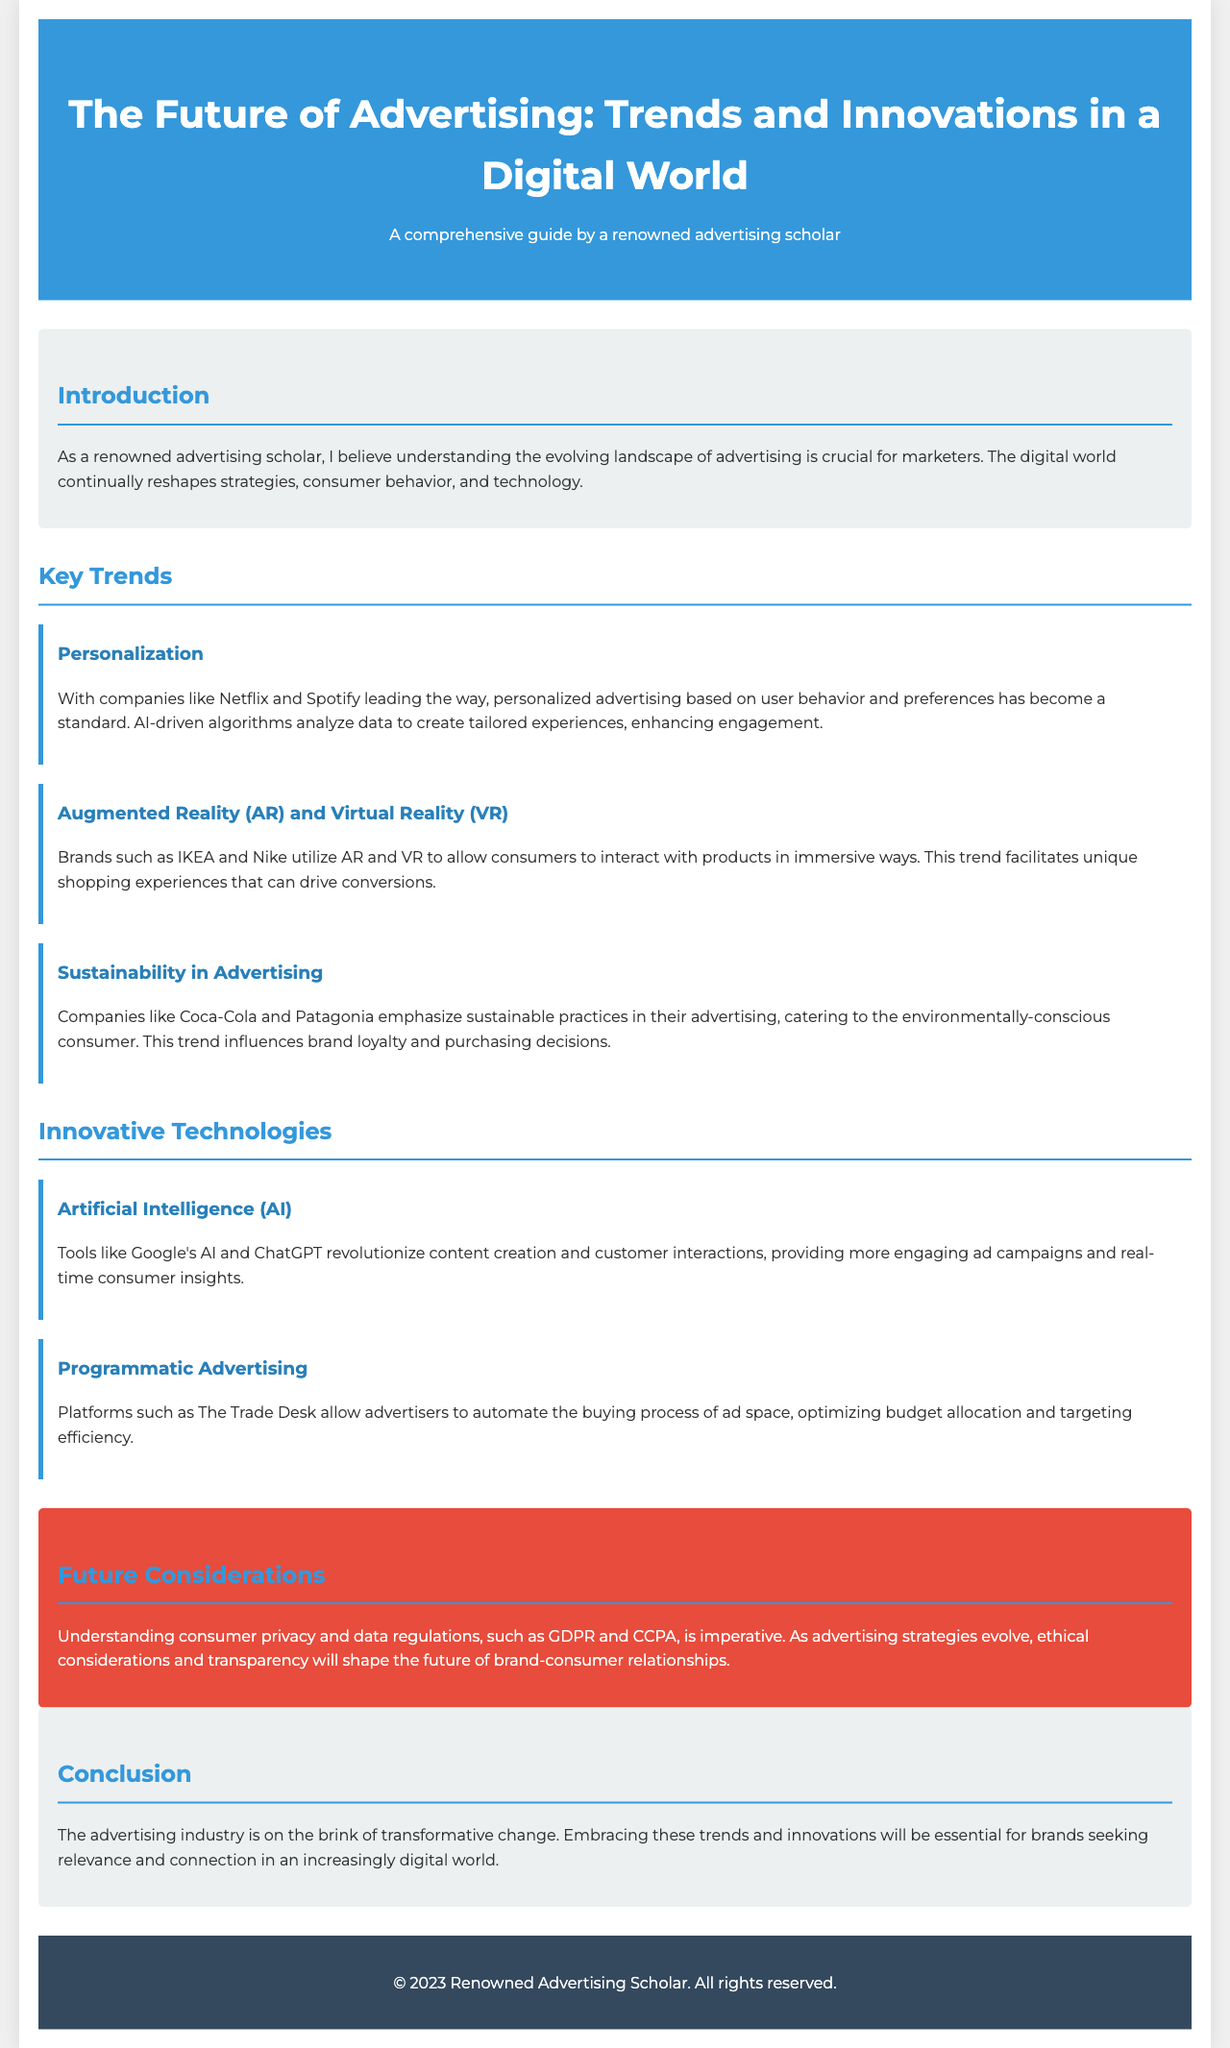what is the title of the brochure? The title is stated at the top of the document as the main heading.
Answer: The Future of Advertising: Trends and Innovations in a Digital World who is the author of the brochure? The author is mentioned in the footer of the document.
Answer: A renowned advertising scholar what are two examples of companies mentioned that utilize personalized advertising? The document references specific companies in the context of personalized advertising.
Answer: Netflix and Spotify what innovative technology is responsible for revolutionizing content creation? This information can be found in the section discussing innovative technologies.
Answer: Artificial Intelligence (AI) what are the three key trends covered in the brochure? The brochure lists specific trends under the section titled "Key Trends."
Answer: Personalization, Augmented Reality (AR) and Virtual Reality (VR), Sustainability in Advertising what is a critical consideration for the future of advertising according to the document? The document highlights important aspects for future strategies in the "Future Considerations" section.
Answer: Consumer privacy and data regulations how does sustainability influence consumer behavior according to the brochure? The document explains the impact of sustainability on purchasing decisions in the relevant section.
Answer: Brand loyalty what kind of advertising does programmatic advertising improve? The document describes the effects of programmatic advertising in terms of efficiency in a specific area.
Answer: Targeting efficiency 